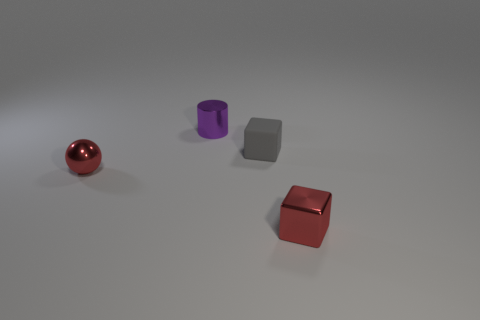Are there any objects in the picture that could provide an indication of size or scale? Without additional context or known reference objects in the image, it's challenging to determine the scale or size of the objects depicted accurately. 